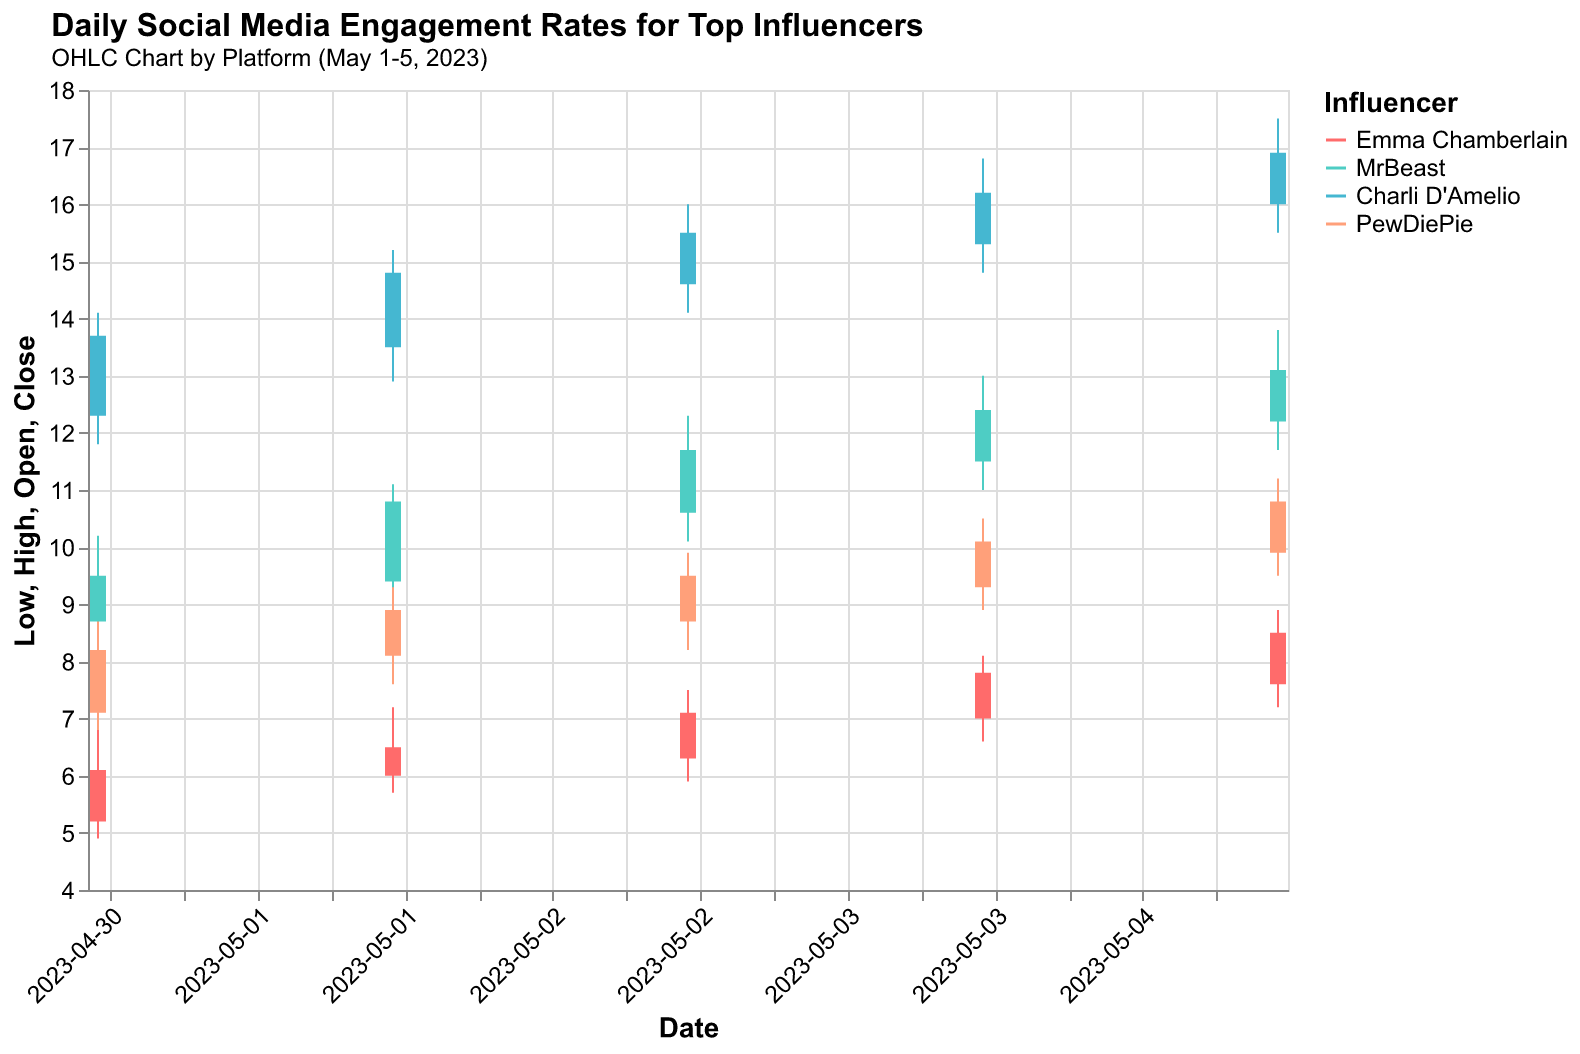what is the highest engagement rate recorded for MrBeast on YouTube? To find the highest engagement rate for MrBeast on YouTube, look for the highest "High" value recorded in the data. This value is 13.8 on May 5, 2023.
Answer: 13.8 what does OHLC stand for in the context of this chart? OHLC stands for Open, High, Low, and Close. These represent four key data points for each date: the opening engagement rate, the highest rate during the day, the lowest rate during the day, and the closing engagement rate.
Answer: Open, High, Low, Close which influencer showed the highest increase in engagement rates on a single day, and what was the value? Look for the highest "Close" value minus the corresponding "Open" value for each influencer across all dates. Charli D'Amelio had the highest increase on May 1, 2023, with an increase from 12.3 to 13.7, a difference of 1.4.
Answer: Charli D'Amelio, 1.4 compare the engagement rates of PewDiePie and Charli D'Amelio on May 2, 2023. Who had higher rates, and by how much? Look at the "Close" values for both influencers on May 2. Charli D'Amelio had a closing rate of 14.8 while PewDiePie had 8.9. The difference is 14.8 - 8.9 = 5.9.
Answer: Charli D'Amelio, 5.9 how did Emma Chamberlain’s engagement rate on Instagram change from May 1st to May 5th? Examine the "Close" values for Emma Chamberlain's Instagram engagement rates from May 1 to May 5. The values are 6.1, 6.5, 7.1, 7.8, and 8.5, respectively, showing a steady increase.
Answer: Increased between the platforms used by the influencers, which showed the smallest volatility in engagement rates, and for which influencer? Examine the High-Low ranges for each influencer on their respective platforms across the dates. Emma Chamberlain on Instagram shows the smallest ranges, with differences around 1.5.
Answer: Emma Chamberlain, Instagram what is the average closing engagement rate for PewDiePie on YouTube over the five days? Add up all the “Close” values for PewDiePie from May 1 to May 5 (8.2, 8.9, 9.5, 10.1, 10.8) and then divide by 5. The sum is 47.5 and the average is 47.5/5 = 9.5.
Answer: 9.5 did any influencer experience a drop in engagement rate on May 3rd? Compare the "Open" and "Close" values for each influencer on May 3rd. None of the influencers had a lower closing value than their opening value on this day.
Answer: No which influencer had the highest closing engagement rate on May 5, and what was the value? On May 5, compare the "Close" values for all influencers. Charli D'Amelio had the highest closing engagement rate at 16.9.
Answer: Charli D'Amelio, 16.9 